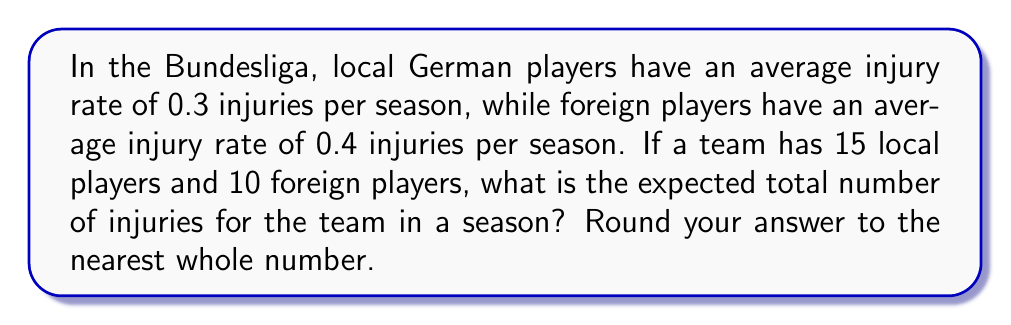Can you answer this question? Let's approach this step-by-step using the concept of expected value in stochastic processes:

1) For local players:
   - Number of local players = 15
   - Injury rate for local players = 0.3 injuries/season
   - Expected injuries for local players = $15 \times 0.3 = 4.5$

2) For foreign players:
   - Number of foreign players = 10
   - Injury rate for foreign players = 0.4 injuries/season
   - Expected injuries for foreign players = $10 \times 0.4 = 4$

3) Total expected injuries:
   $$E[\text{Total Injuries}] = E[\text{Local Injuries}] + E[\text{Foreign Injuries}]$$
   $$E[\text{Total Injuries}] = 4.5 + 4 = 8.5$$

4) Rounding to the nearest whole number:
   8.5 rounds to 9

Therefore, the expected total number of injuries for the team in a season is 9.
Answer: 9 injuries 